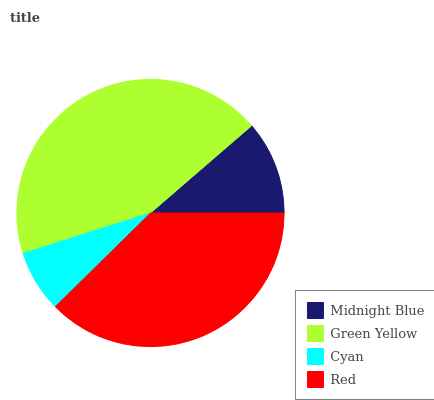Is Cyan the minimum?
Answer yes or no. Yes. Is Green Yellow the maximum?
Answer yes or no. Yes. Is Green Yellow the minimum?
Answer yes or no. No. Is Cyan the maximum?
Answer yes or no. No. Is Green Yellow greater than Cyan?
Answer yes or no. Yes. Is Cyan less than Green Yellow?
Answer yes or no. Yes. Is Cyan greater than Green Yellow?
Answer yes or no. No. Is Green Yellow less than Cyan?
Answer yes or no. No. Is Red the high median?
Answer yes or no. Yes. Is Midnight Blue the low median?
Answer yes or no. Yes. Is Midnight Blue the high median?
Answer yes or no. No. Is Green Yellow the low median?
Answer yes or no. No. 